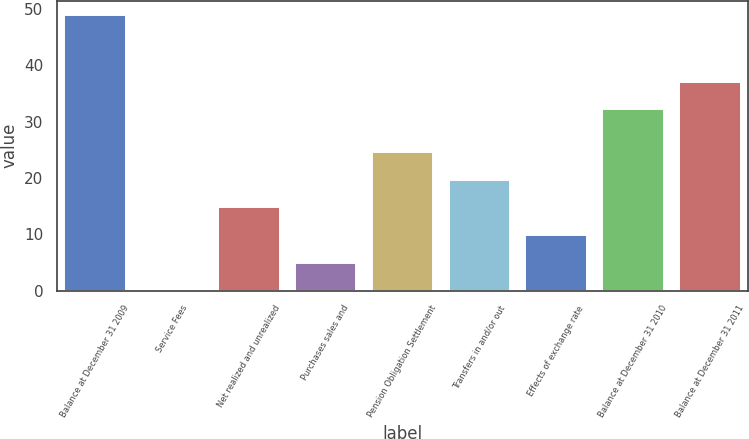<chart> <loc_0><loc_0><loc_500><loc_500><bar_chart><fcel>Balance at December 31 2009<fcel>Service Fees<fcel>Net realized and unrealized<fcel>Purchases sales and<fcel>Pension Obligation Settlement<fcel>Transfers in and/or out<fcel>Effects of exchange rate<fcel>Balance at December 31 2010<fcel>Balance at December 31 2011<nl><fcel>49<fcel>0.1<fcel>14.77<fcel>4.99<fcel>24.55<fcel>19.66<fcel>9.88<fcel>32.2<fcel>37.09<nl></chart> 